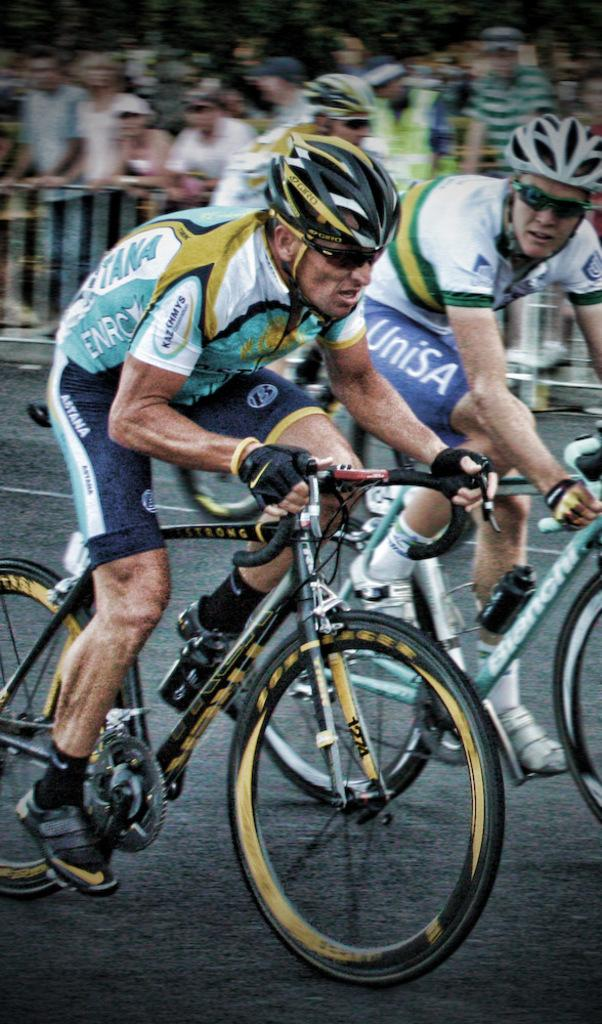How many people are in the image? There are two people in the image. What are the two people wearing? The two people are wearing helmets. What activity are the two people engaged in? The two people are riding bicycles. What can be observed about the group of people in the background? The group of people are watching the two people riding bicycles. What is the profit margin of the church in the image? There is no church present in the image, so it is not possible to determine its profit margin. 